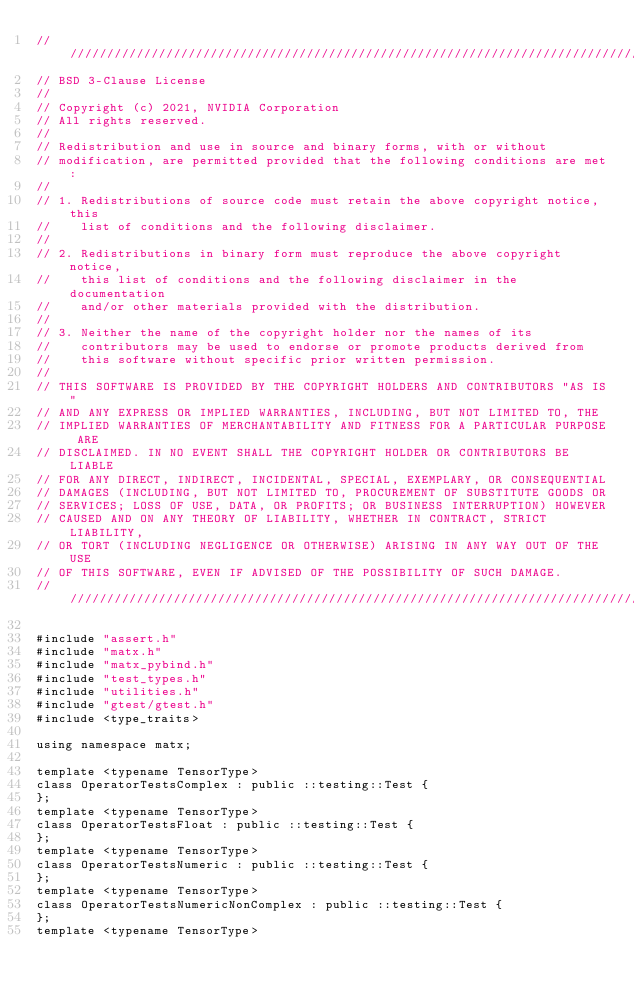Convert code to text. <code><loc_0><loc_0><loc_500><loc_500><_Cuda_>////////////////////////////////////////////////////////////////////////////////
// BSD 3-Clause License
//
// Copyright (c) 2021, NVIDIA Corporation
// All rights reserved.
//
// Redistribution and use in source and binary forms, with or without
// modification, are permitted provided that the following conditions are met:
//
// 1. Redistributions of source code must retain the above copyright notice, this
//    list of conditions and the following disclaimer.
//
// 2. Redistributions in binary form must reproduce the above copyright notice,
//    this list of conditions and the following disclaimer in the documentation
//    and/or other materials provided with the distribution.
//
// 3. Neither the name of the copyright holder nor the names of its
//    contributors may be used to endorse or promote products derived from
//    this software without specific prior written permission.
//
// THIS SOFTWARE IS PROVIDED BY THE COPYRIGHT HOLDERS AND CONTRIBUTORS "AS IS"
// AND ANY EXPRESS OR IMPLIED WARRANTIES, INCLUDING, BUT NOT LIMITED TO, THE
// IMPLIED WARRANTIES OF MERCHANTABILITY AND FITNESS FOR A PARTICULAR PURPOSE ARE
// DISCLAIMED. IN NO EVENT SHALL THE COPYRIGHT HOLDER OR CONTRIBUTORS BE LIABLE
// FOR ANY DIRECT, INDIRECT, INCIDENTAL, SPECIAL, EXEMPLARY, OR CONSEQUENTIAL
// DAMAGES (INCLUDING, BUT NOT LIMITED TO, PROCUREMENT OF SUBSTITUTE GOODS OR
// SERVICES; LOSS OF USE, DATA, OR PROFITS; OR BUSINESS INTERRUPTION) HOWEVER
// CAUSED AND ON ANY THEORY OF LIABILITY, WHETHER IN CONTRACT, STRICT LIABILITY,
// OR TORT (INCLUDING NEGLIGENCE OR OTHERWISE) ARISING IN ANY WAY OUT OF THE USE
// OF THIS SOFTWARE, EVEN IF ADVISED OF THE POSSIBILITY OF SUCH DAMAGE.
/////////////////////////////////////////////////////////////////////////////////

#include "assert.h"
#include "matx.h"
#include "matx_pybind.h"
#include "test_types.h"
#include "utilities.h"
#include "gtest/gtest.h"
#include <type_traits>

using namespace matx;

template <typename TensorType>
class OperatorTestsComplex : public ::testing::Test {
};
template <typename TensorType>
class OperatorTestsFloat : public ::testing::Test {
};
template <typename TensorType>
class OperatorTestsNumeric : public ::testing::Test {
};
template <typename TensorType>
class OperatorTestsNumericNonComplex : public ::testing::Test {
};
template <typename TensorType></code> 